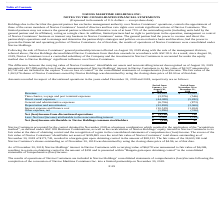From Navios Maritime Holdings's financial document, Which years does the table provide information for discontinued operations? The document shows two values: 2019 and 2018. From the document: "neral partnership interest effected on August 30, 2019 along with the sale of the management division, referred above, Navios Holdings deconsolidated ..." Also, What was the revenue in 2018? According to the financial document, 12,053 (in thousands). The relevant text states: "Revenue $ 89,925 $ 12,053..." Also, What were the General and administrative expenses in 2018? According to the financial document, (873) (in thousands). The relevant text states: "General and administrative expenses (6,706) (873)..." Also, How many years did revenue exceed $50,000 thousand? Based on the analysis, there are 1 instances. The counting process: 2019. Also, can you calculate: What was the change in direct vessel expenses between 2018 and 2019? Based on the calculation: -44,088-(-5,282), the result is -38806 (in thousands). This is based on the information: "Direct vessel expenses (44,088) (5,282) Direct vessel expenses (44,088) (5,282)..." The key data points involved are: 44,088, 5,282. Also, can you calculate: What was the percentage change in Interest expense and finance cost between 2018 and 2019? To answer this question, I need to perform calculations using the financial data. The calculation is: (-10,519-(-1,204))/-1,204, which equals 773.67 (percentage). This is based on the information: "Interest expense and finance cost (10,519) (1,204) Interest expense and finance cost (10,519) (1,204)..." The key data points involved are: 1,204, 10,519. 